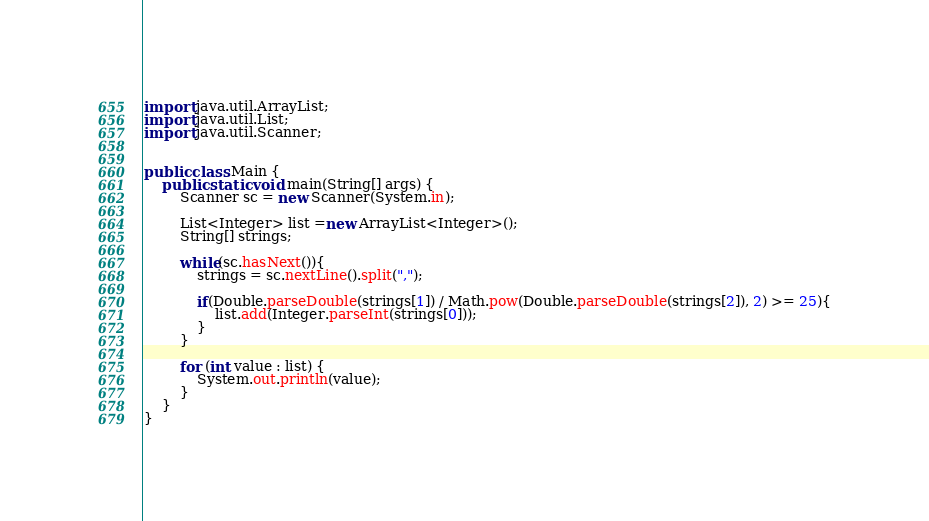Convert code to text. <code><loc_0><loc_0><loc_500><loc_500><_Java_>import java.util.ArrayList;
import java.util.List;
import java.util.Scanner;


public class Main {
	public static void main(String[] args) {
		Scanner sc = new Scanner(System.in);

		List<Integer> list =new ArrayList<Integer>();
		String[] strings;

		while(sc.hasNext()){
			strings = sc.nextLine().split(",");

			if(Double.parseDouble(strings[1]) / Math.pow(Double.parseDouble(strings[2]), 2) >= 25){
				list.add(Integer.parseInt(strings[0]));
			}
		}

		for (int value : list) {
			System.out.println(value);
		}
	}
}</code> 